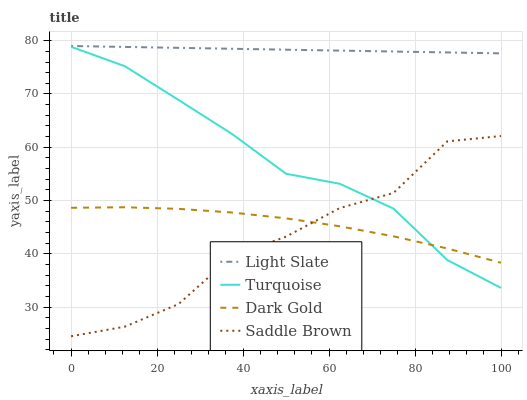Does Saddle Brown have the minimum area under the curve?
Answer yes or no. Yes. Does Light Slate have the maximum area under the curve?
Answer yes or no. Yes. Does Turquoise have the minimum area under the curve?
Answer yes or no. No. Does Turquoise have the maximum area under the curve?
Answer yes or no. No. Is Light Slate the smoothest?
Answer yes or no. Yes. Is Saddle Brown the roughest?
Answer yes or no. Yes. Is Turquoise the smoothest?
Answer yes or no. No. Is Turquoise the roughest?
Answer yes or no. No. Does Saddle Brown have the lowest value?
Answer yes or no. Yes. Does Turquoise have the lowest value?
Answer yes or no. No. Does Light Slate have the highest value?
Answer yes or no. Yes. Does Turquoise have the highest value?
Answer yes or no. No. Is Dark Gold less than Light Slate?
Answer yes or no. Yes. Is Light Slate greater than Turquoise?
Answer yes or no. Yes. Does Saddle Brown intersect Dark Gold?
Answer yes or no. Yes. Is Saddle Brown less than Dark Gold?
Answer yes or no. No. Is Saddle Brown greater than Dark Gold?
Answer yes or no. No. Does Dark Gold intersect Light Slate?
Answer yes or no. No. 